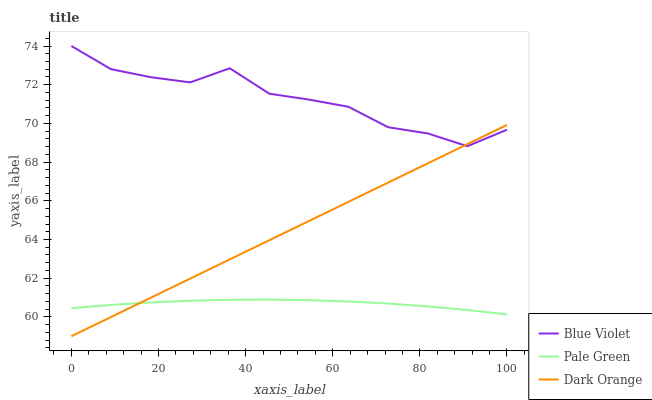Does Pale Green have the minimum area under the curve?
Answer yes or no. Yes. Does Blue Violet have the maximum area under the curve?
Answer yes or no. Yes. Does Blue Violet have the minimum area under the curve?
Answer yes or no. No. Does Pale Green have the maximum area under the curve?
Answer yes or no. No. Is Dark Orange the smoothest?
Answer yes or no. Yes. Is Blue Violet the roughest?
Answer yes or no. Yes. Is Pale Green the smoothest?
Answer yes or no. No. Is Pale Green the roughest?
Answer yes or no. No. Does Dark Orange have the lowest value?
Answer yes or no. Yes. Does Pale Green have the lowest value?
Answer yes or no. No. Does Blue Violet have the highest value?
Answer yes or no. Yes. Does Pale Green have the highest value?
Answer yes or no. No. Is Pale Green less than Blue Violet?
Answer yes or no. Yes. Is Blue Violet greater than Pale Green?
Answer yes or no. Yes. Does Blue Violet intersect Dark Orange?
Answer yes or no. Yes. Is Blue Violet less than Dark Orange?
Answer yes or no. No. Is Blue Violet greater than Dark Orange?
Answer yes or no. No. Does Pale Green intersect Blue Violet?
Answer yes or no. No. 